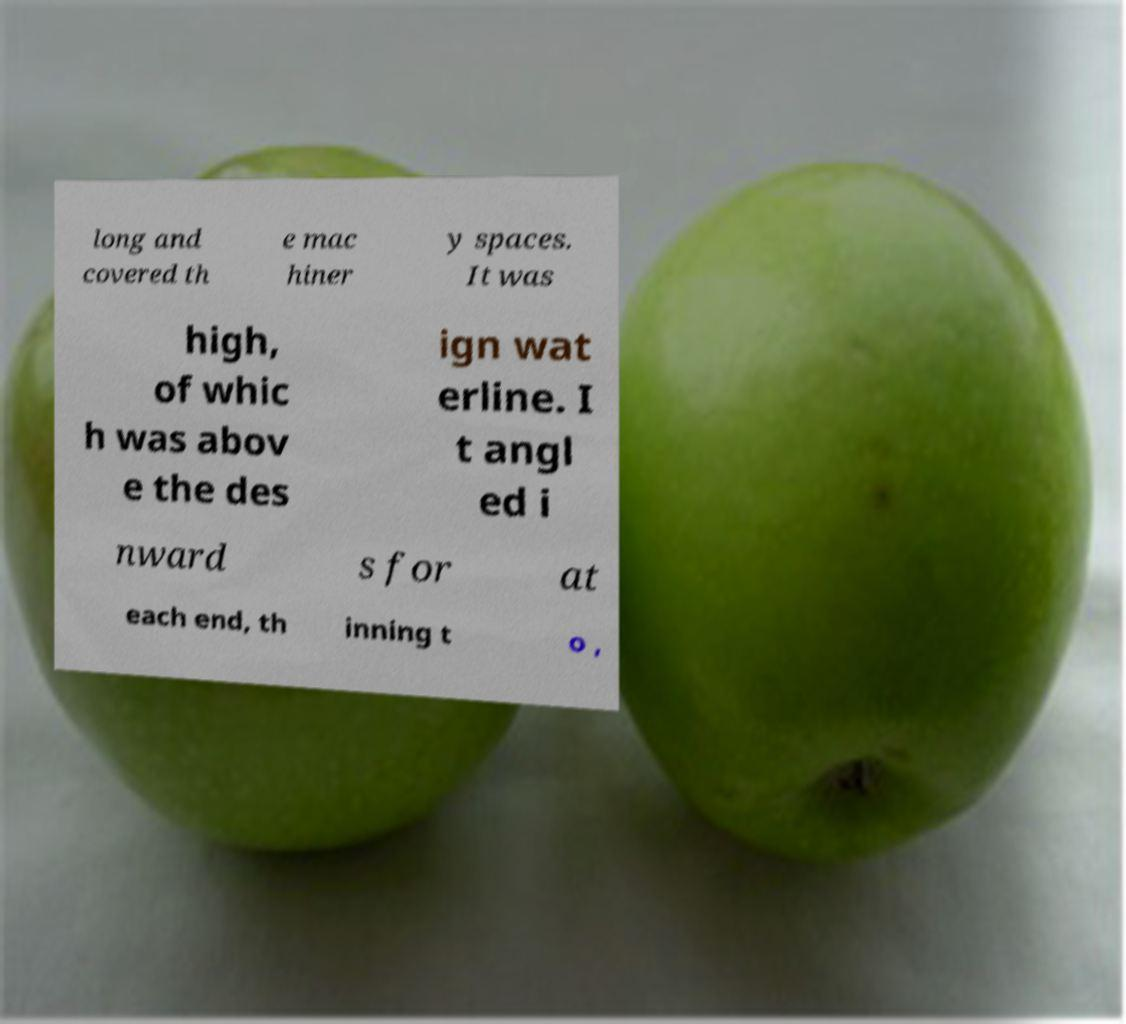Could you assist in decoding the text presented in this image and type it out clearly? long and covered th e mac hiner y spaces. It was high, of whic h was abov e the des ign wat erline. I t angl ed i nward s for at each end, th inning t o , 